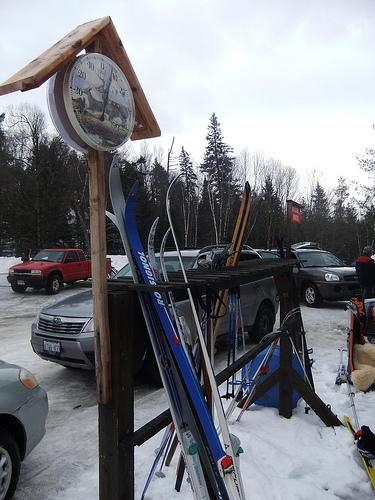Provide information about the central event in the image and describe it briefly. An eager skier donning appropriate ski wear, preparing to ski down a powdered hill close to a picturesque ski lodge, has their skiing equipment stowed in a ski holder. What is the essential theme of the photo and its depiction? A skier in winter gear ready for a ski session on the snow-laden hill next to a ski lodge, with their skis and ski poles set in a ski rack. Describe the image's chief subject and their actions. A ski enthusiast wearing appropriate ski attire, getting ready to glide down the snow-covered hill by the ski lodge, has their skiing gear placed in a ski rack. Point out the prominent subject of the image and discuss their undertaking. The main subject is an individual in ski attire, preparing for an enjoyable skiing experience on the snow-covered ground near a ski lodge, with skiing equipment placed in a ski rack. Tell me what the main object in the image is and what it's doing. The main object is someone dressed in skiing clothes, preparing for skiing on a snowy slope near a warm ski lodge, with their skiing equipment nearby. Express the main idea of the image and describe the ongoing event. A skiing lover, clad in ski clothing, about to embark on an exciting run along the snow-capped hill next to a ski lodge, has put their skiing tools in a ski rack. Illustrate the image's dominant scene and the activity happening in it. An individual in ski outerwear, prepping for a ski course down the snowy slope near a welcoming ski lodge, stores their skis and poles in a ski rack. Identify the central element in the image and describe its activity. The primary scene in the image is an individual in skiing attire preparing to descend a snow-covered slope beside a cozy ski lodge, with skis and poles nearby. Note the essential component in the photograph and describe its actions. The critical component of the photo is a skier clad in winter gear, getting ready to descend the snow-coated slope near a ski lodge, with their skiing essentials stored nearby in a rack. Mention the primary focal point of the image and their action. A person wearing ski gear is getting ready to ski on the snowy ground near a ski lodge, with their skis and poles in a ski rack. 